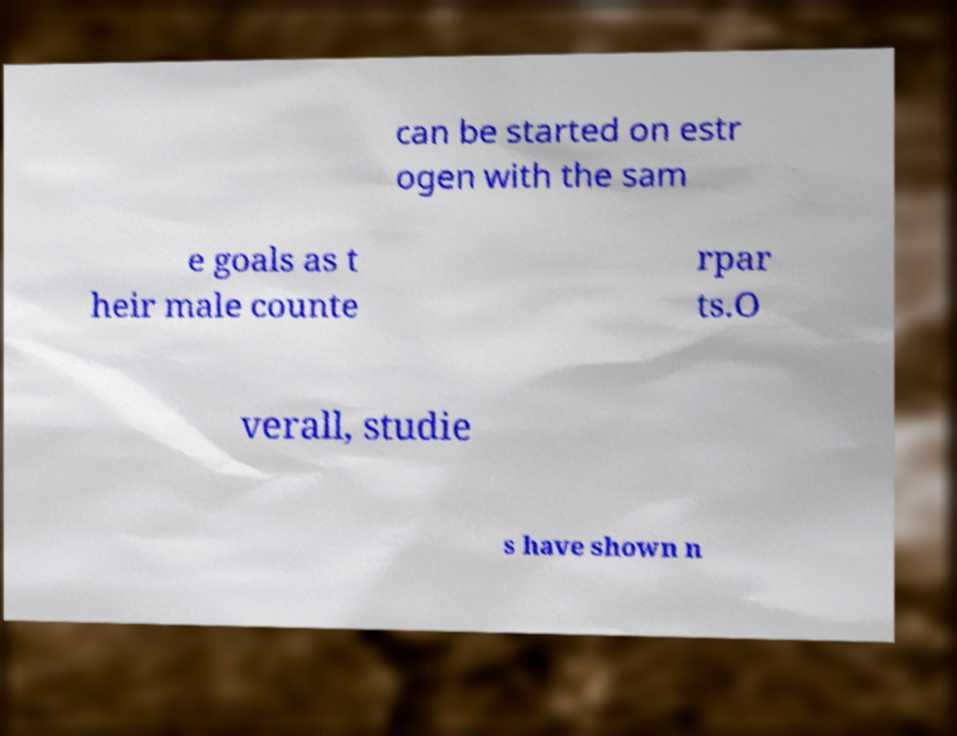Could you extract and type out the text from this image? can be started on estr ogen with the sam e goals as t heir male counte rpar ts.O verall, studie s have shown n 